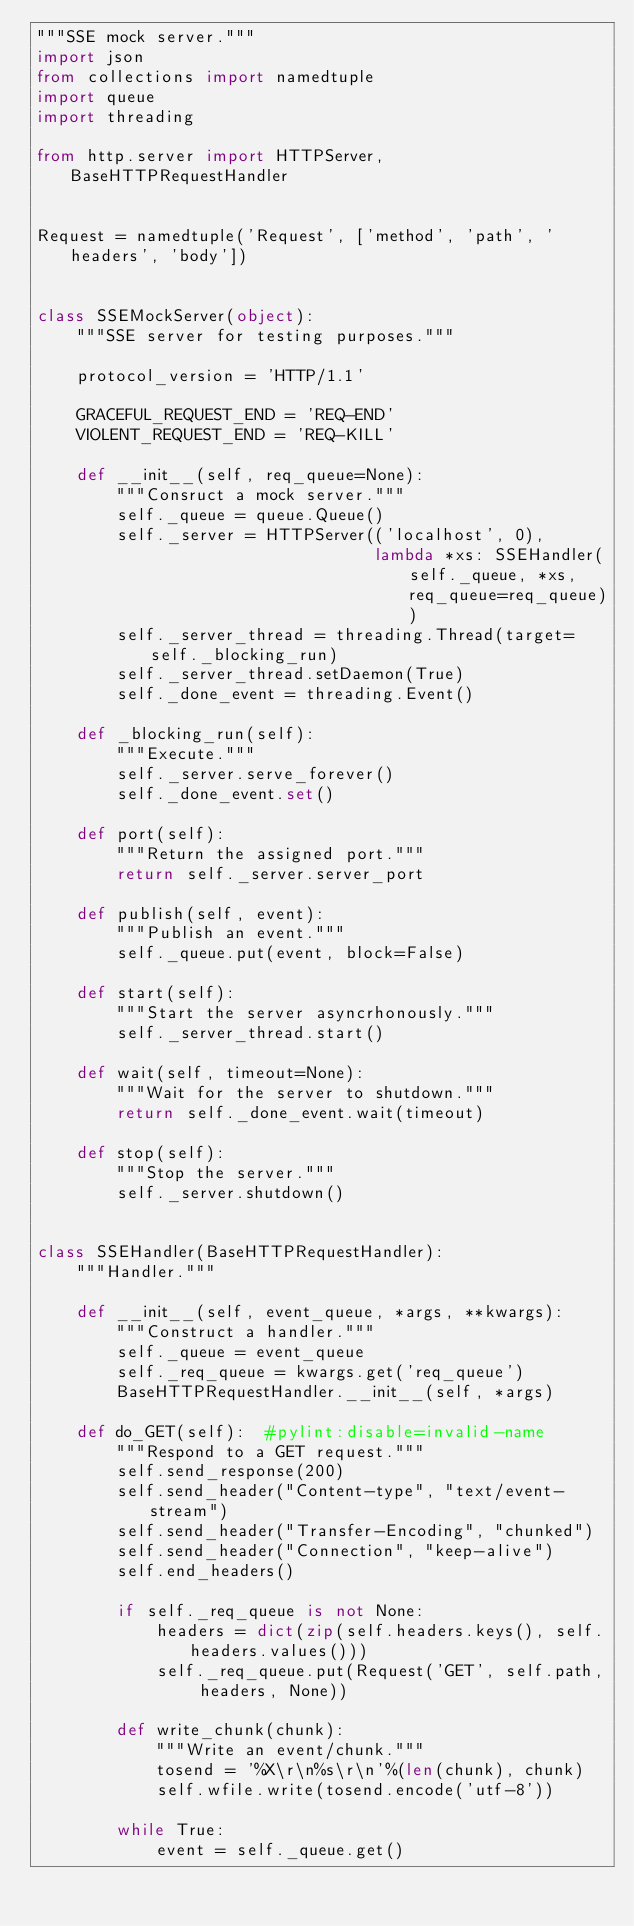Convert code to text. <code><loc_0><loc_0><loc_500><loc_500><_Python_>"""SSE mock server."""
import json
from collections import namedtuple
import queue
import threading

from http.server import HTTPServer, BaseHTTPRequestHandler


Request = namedtuple('Request', ['method', 'path', 'headers', 'body'])


class SSEMockServer(object):
    """SSE server for testing purposes."""

    protocol_version = 'HTTP/1.1'

    GRACEFUL_REQUEST_END = 'REQ-END'
    VIOLENT_REQUEST_END = 'REQ-KILL'

    def __init__(self, req_queue=None):
        """Consruct a mock server."""
        self._queue = queue.Queue()
        self._server = HTTPServer(('localhost', 0),
                                  lambda *xs: SSEHandler(self._queue, *xs, req_queue=req_queue))
        self._server_thread = threading.Thread(target=self._blocking_run)
        self._server_thread.setDaemon(True)
        self._done_event = threading.Event()

    def _blocking_run(self):
        """Execute."""
        self._server.serve_forever()
        self._done_event.set()

    def port(self):
        """Return the assigned port."""
        return self._server.server_port

    def publish(self, event):
        """Publish an event."""
        self._queue.put(event, block=False)

    def start(self):
        """Start the server asyncrhonously."""
        self._server_thread.start()

    def wait(self, timeout=None):
        """Wait for the server to shutdown."""
        return self._done_event.wait(timeout)

    def stop(self):
        """Stop the server."""
        self._server.shutdown()


class SSEHandler(BaseHTTPRequestHandler):
    """Handler."""

    def __init__(self, event_queue, *args, **kwargs):
        """Construct a handler."""
        self._queue = event_queue
        self._req_queue = kwargs.get('req_queue')
        BaseHTTPRequestHandler.__init__(self, *args)

    def do_GET(self):  #pylint:disable=invalid-name
        """Respond to a GET request."""
        self.send_response(200)
        self.send_header("Content-type", "text/event-stream")
        self.send_header("Transfer-Encoding", "chunked")
        self.send_header("Connection", "keep-alive")
        self.end_headers()

        if self._req_queue is not None:
            headers = dict(zip(self.headers.keys(), self.headers.values()))
            self._req_queue.put(Request('GET', self.path, headers, None))

        def write_chunk(chunk):
            """Write an event/chunk."""
            tosend = '%X\r\n%s\r\n'%(len(chunk), chunk)
            self.wfile.write(tosend.encode('utf-8'))

        while True:
            event = self._queue.get()</code> 